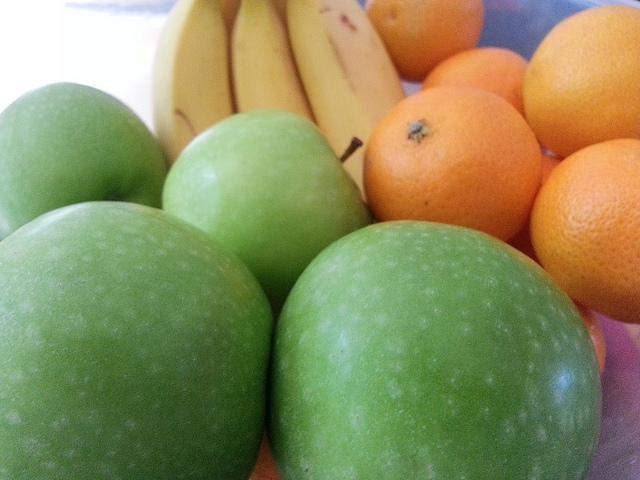What is the green item used in? Please explain your reasoning. apple pie. The green item in question is an apple based on the color, shape size and skin. this would be a main ingredient in answer a and none of the other answers. 